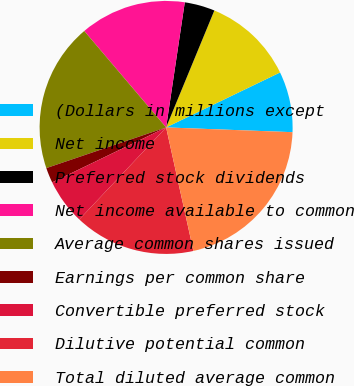<chart> <loc_0><loc_0><loc_500><loc_500><pie_chart><fcel>(Dollars in millions except<fcel>Net income<fcel>Preferred stock dividends<fcel>Net income available to common<fcel>Average common shares issued<fcel>Earnings per common share<fcel>Convertible preferred stock<fcel>Dilutive potential common<fcel>Total diluted average common<nl><fcel>7.75%<fcel>11.62%<fcel>3.87%<fcel>13.56%<fcel>19.01%<fcel>1.94%<fcel>5.81%<fcel>15.5%<fcel>20.94%<nl></chart> 